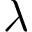<formula> <loc_0><loc_0><loc_500><loc_500>\lambda</formula> 